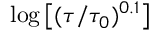<formula> <loc_0><loc_0><loc_500><loc_500>\log \left [ ( \tau / \tau _ { 0 } ) ^ { 0 . 1 } \right ]</formula> 